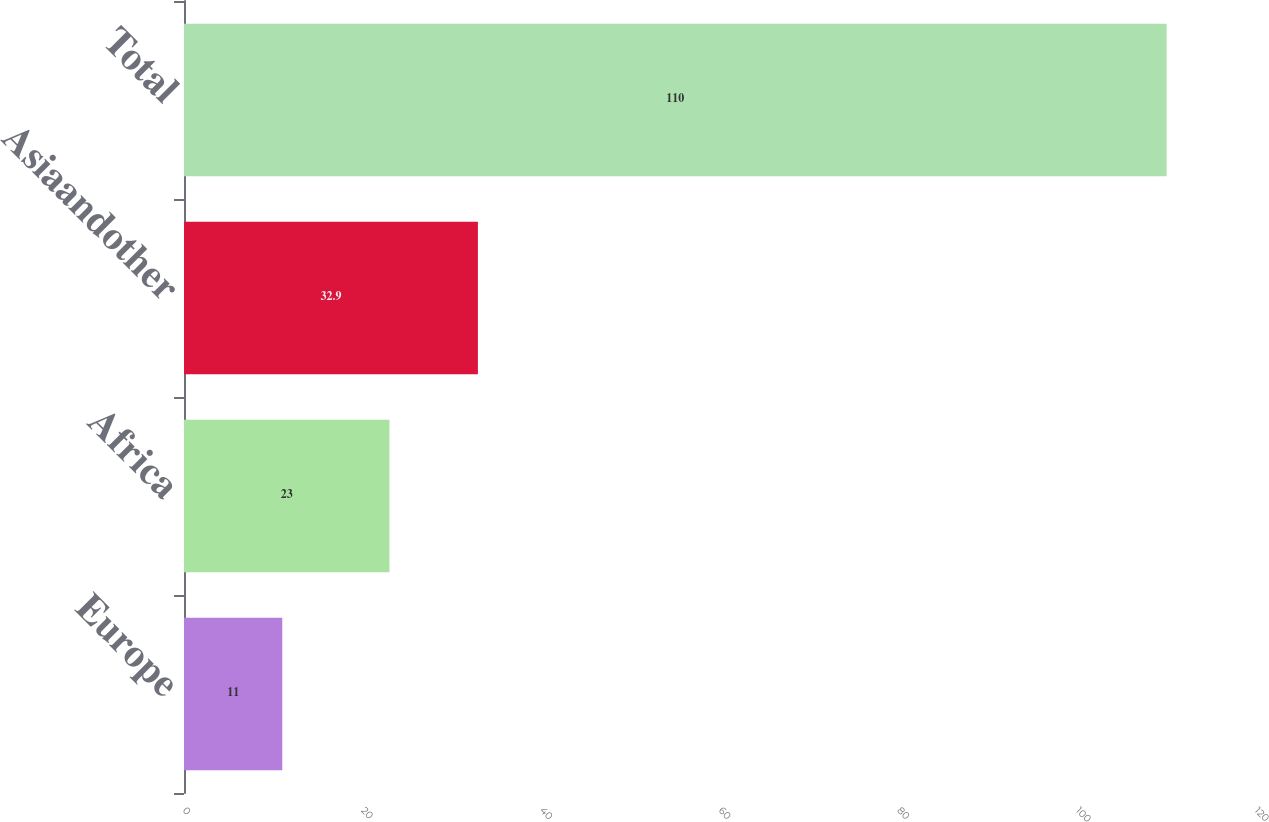<chart> <loc_0><loc_0><loc_500><loc_500><bar_chart><fcel>Europe<fcel>Africa<fcel>Asiaandother<fcel>Total<nl><fcel>11<fcel>23<fcel>32.9<fcel>110<nl></chart> 